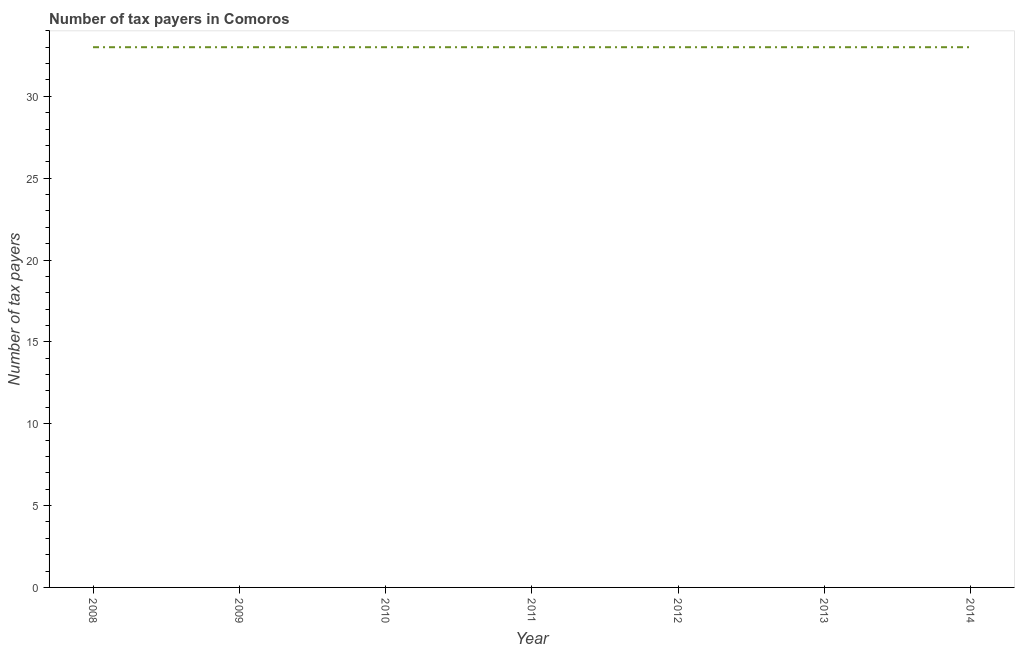What is the number of tax payers in 2008?
Make the answer very short. 33. Across all years, what is the maximum number of tax payers?
Your answer should be compact. 33. Across all years, what is the minimum number of tax payers?
Your answer should be compact. 33. In which year was the number of tax payers minimum?
Ensure brevity in your answer.  2008. What is the sum of the number of tax payers?
Your answer should be very brief. 231. What is the difference between the number of tax payers in 2008 and 2014?
Give a very brief answer. 0. What is the average number of tax payers per year?
Provide a short and direct response. 33. What is the median number of tax payers?
Your response must be concise. 33. In how many years, is the number of tax payers greater than 25 ?
Ensure brevity in your answer.  7. Is the number of tax payers in 2010 less than that in 2011?
Keep it short and to the point. No. What is the difference between the highest and the lowest number of tax payers?
Make the answer very short. 0. In how many years, is the number of tax payers greater than the average number of tax payers taken over all years?
Your answer should be very brief. 0. Does the number of tax payers monotonically increase over the years?
Your response must be concise. No. How many years are there in the graph?
Offer a terse response. 7. Does the graph contain grids?
Give a very brief answer. No. What is the title of the graph?
Your answer should be very brief. Number of tax payers in Comoros. What is the label or title of the X-axis?
Your answer should be very brief. Year. What is the label or title of the Y-axis?
Your answer should be very brief. Number of tax payers. What is the Number of tax payers in 2008?
Your answer should be very brief. 33. What is the Number of tax payers in 2011?
Give a very brief answer. 33. What is the difference between the Number of tax payers in 2008 and 2009?
Provide a short and direct response. 0. What is the difference between the Number of tax payers in 2008 and 2010?
Offer a terse response. 0. What is the difference between the Number of tax payers in 2008 and 2011?
Make the answer very short. 0. What is the difference between the Number of tax payers in 2008 and 2012?
Provide a succinct answer. 0. What is the difference between the Number of tax payers in 2008 and 2013?
Give a very brief answer. 0. What is the difference between the Number of tax payers in 2008 and 2014?
Keep it short and to the point. 0. What is the difference between the Number of tax payers in 2009 and 2010?
Provide a short and direct response. 0. What is the difference between the Number of tax payers in 2009 and 2011?
Provide a short and direct response. 0. What is the difference between the Number of tax payers in 2010 and 2011?
Keep it short and to the point. 0. What is the difference between the Number of tax payers in 2011 and 2014?
Make the answer very short. 0. What is the difference between the Number of tax payers in 2012 and 2013?
Keep it short and to the point. 0. What is the difference between the Number of tax payers in 2013 and 2014?
Offer a terse response. 0. What is the ratio of the Number of tax payers in 2008 to that in 2009?
Offer a very short reply. 1. What is the ratio of the Number of tax payers in 2008 to that in 2012?
Ensure brevity in your answer.  1. What is the ratio of the Number of tax payers in 2008 to that in 2013?
Your answer should be compact. 1. What is the ratio of the Number of tax payers in 2008 to that in 2014?
Provide a short and direct response. 1. What is the ratio of the Number of tax payers in 2009 to that in 2010?
Provide a short and direct response. 1. What is the ratio of the Number of tax payers in 2009 to that in 2013?
Ensure brevity in your answer.  1. What is the ratio of the Number of tax payers in 2010 to that in 2011?
Ensure brevity in your answer.  1. 